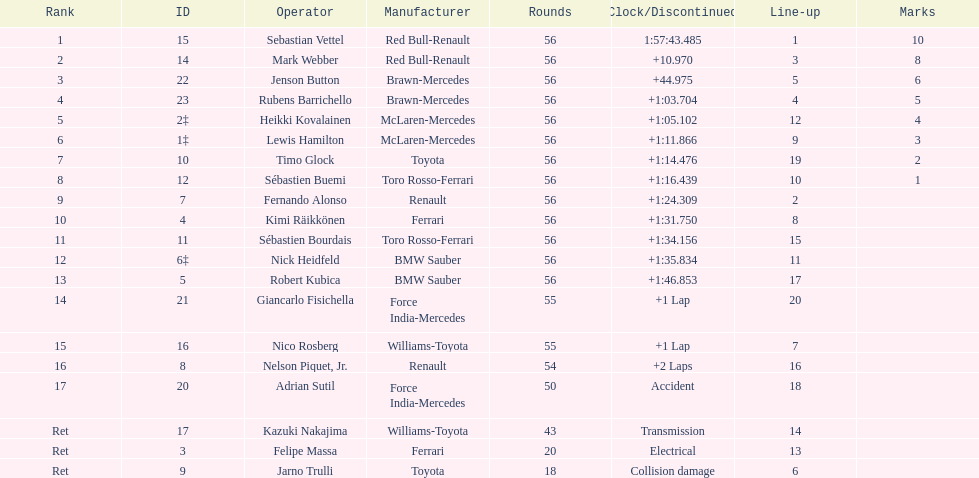What name is just previous to kazuki nakjima on the list? Adrian Sutil. 